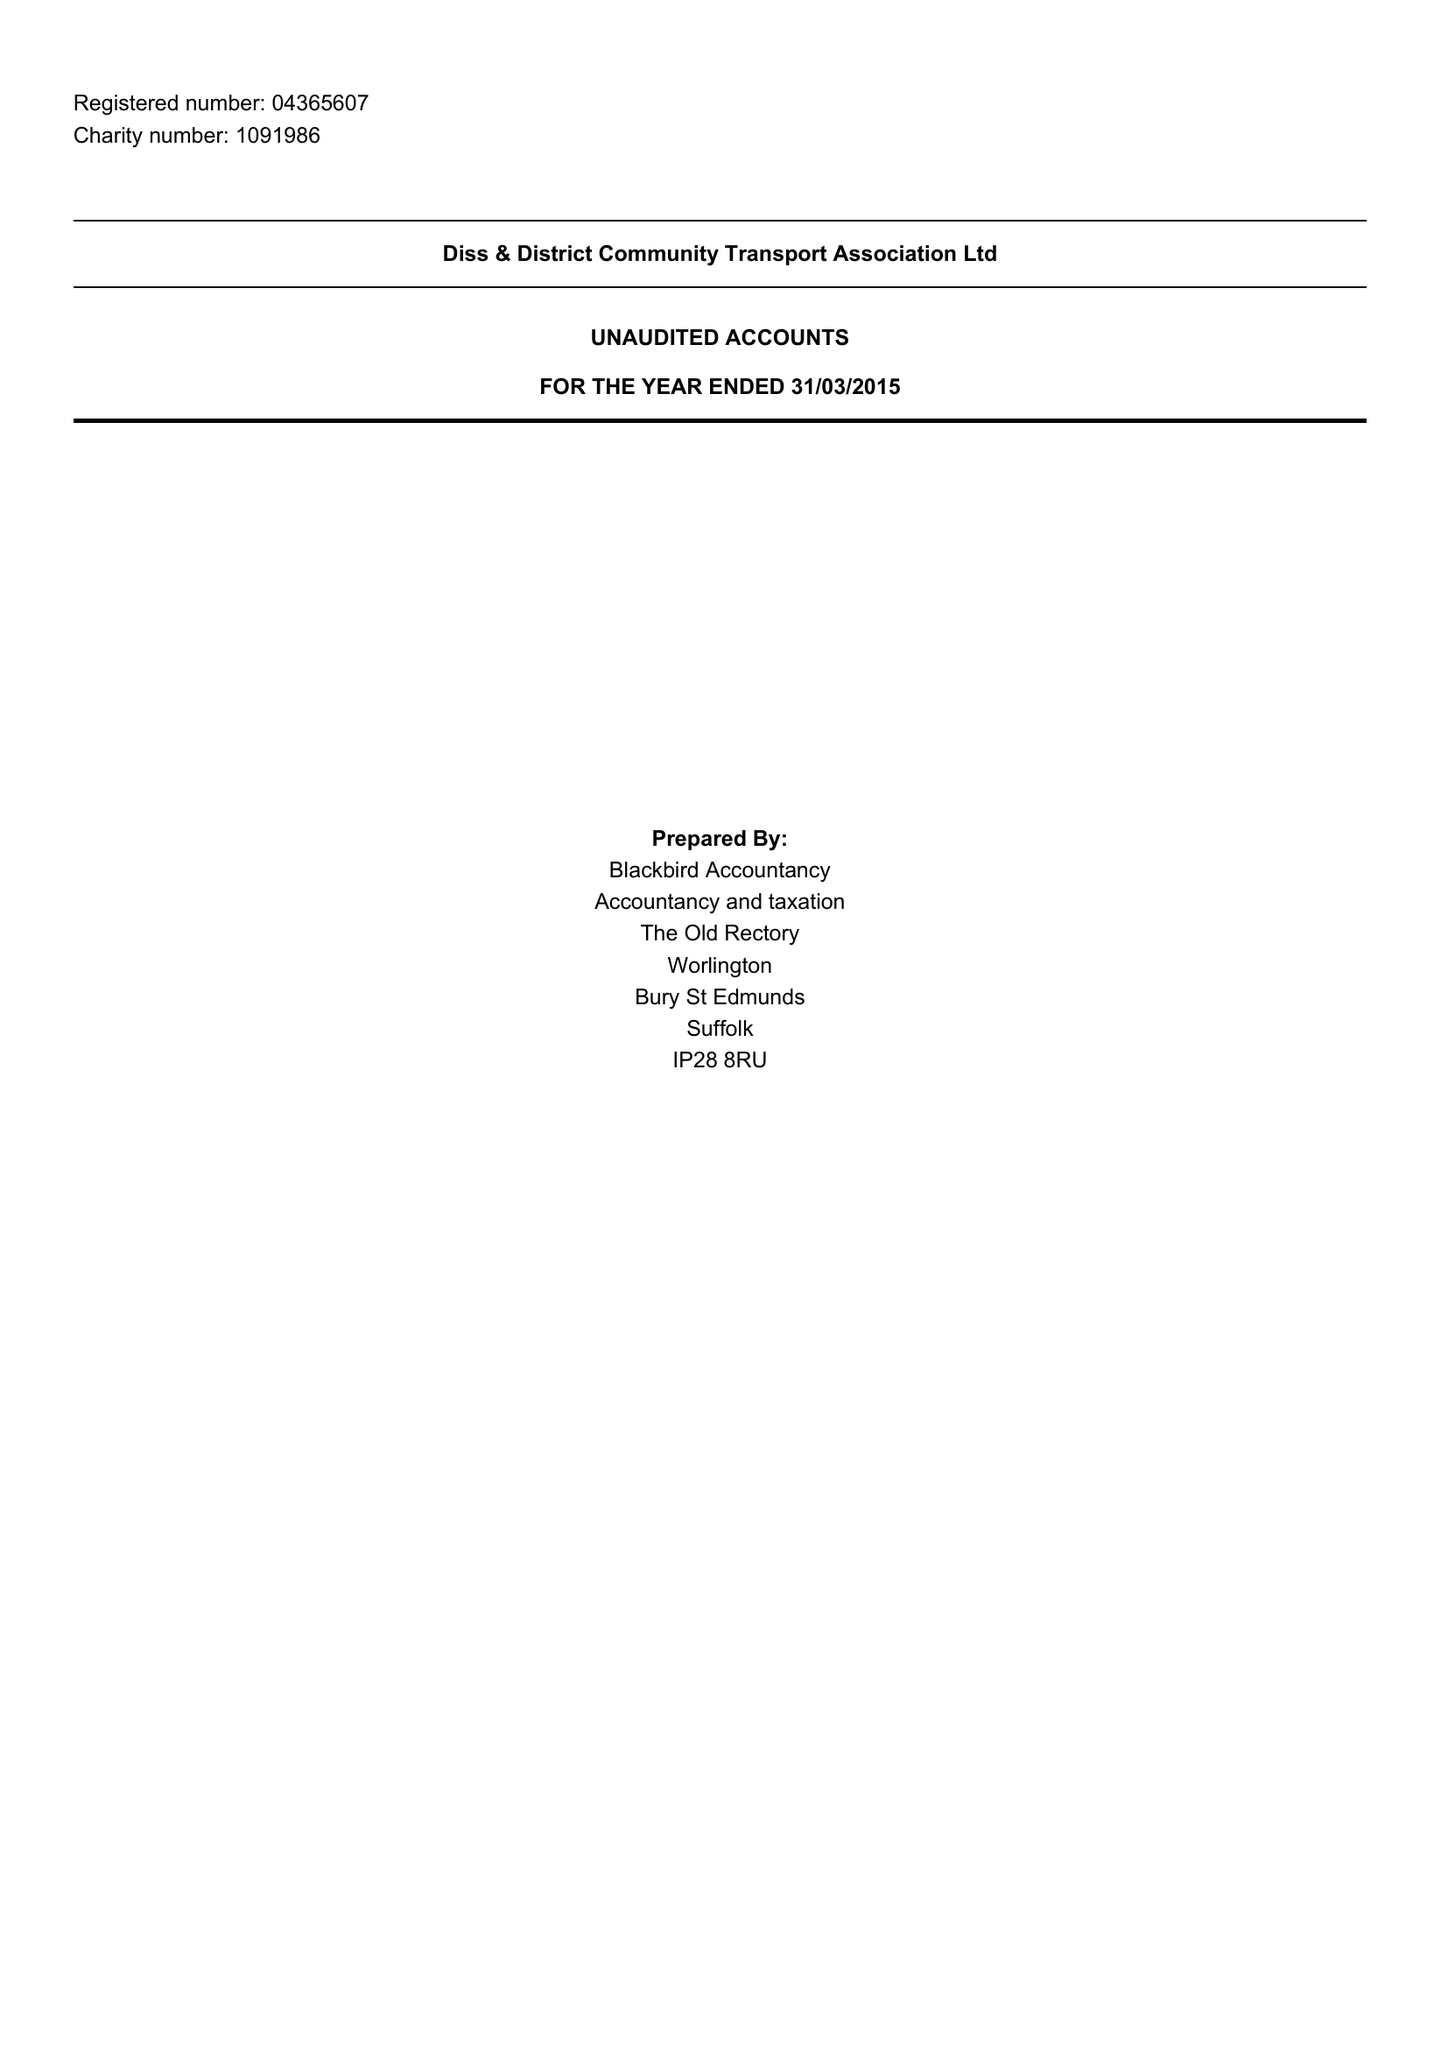What is the value for the address__postcode?
Answer the question using a single word or phrase. IP21 4QD 